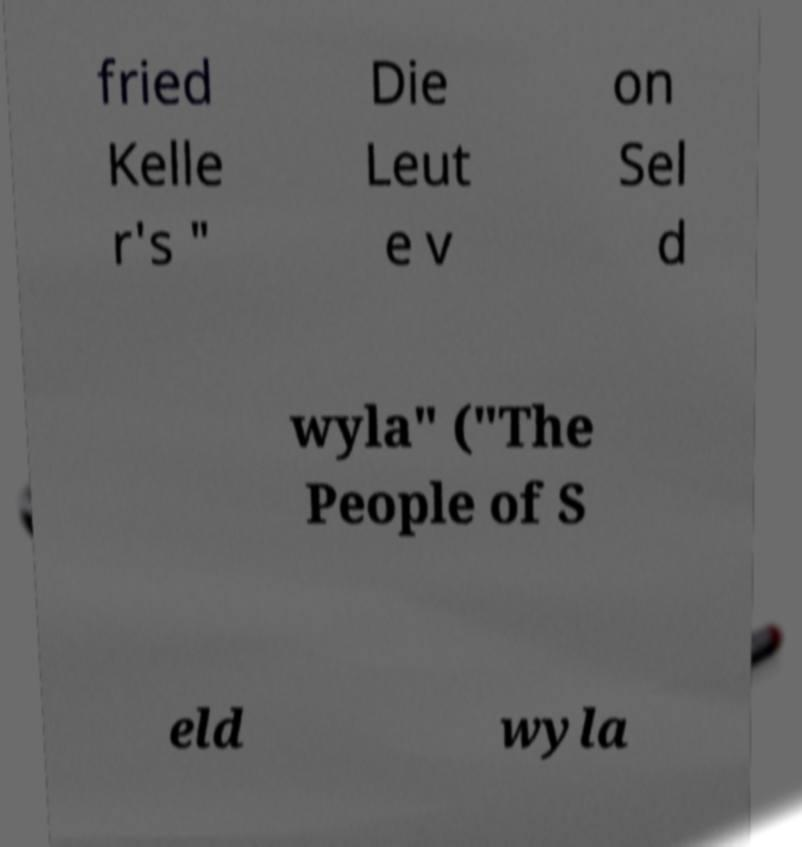Can you accurately transcribe the text from the provided image for me? fried Kelle r's " Die Leut e v on Sel d wyla" ("The People of S eld wyla 